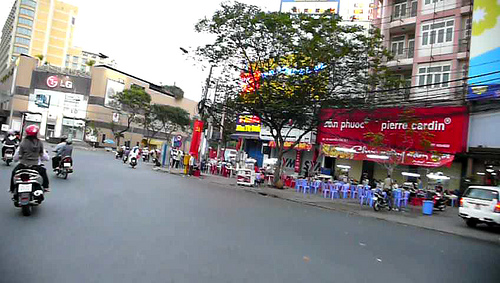Describe the commercial activity visible in the image. The image showcases vibrant commercial activity, with various storefronts including a clothing brand and electronic shops. The presence of ongoing traffic suggests that this is a central commercial area. 